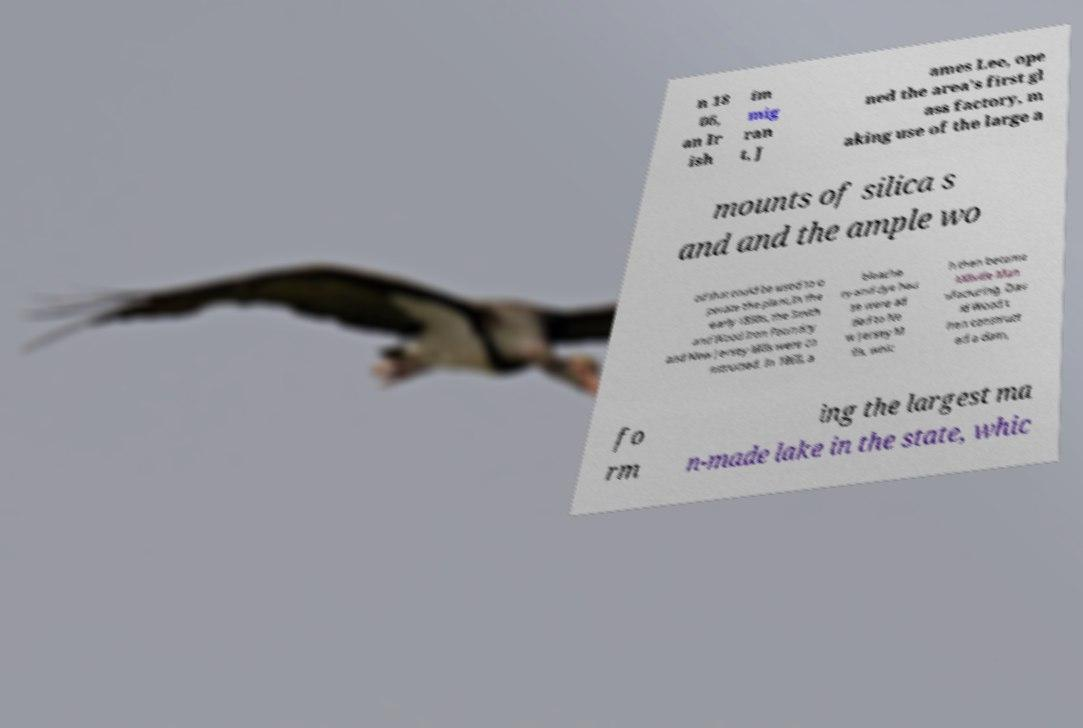I need the written content from this picture converted into text. Can you do that? n 18 06, an Ir ish im mig ran t, J ames Lee, ope ned the area's first gl ass factory, m aking use of the large a mounts of silica s and and the ample wo od that could be used to o perate the plant.In the early 1850s, the Smith and Wood Iron Foundry and New Jersey Mills were co nstructed. In 1860, a bleache ry and dye hou se were ad ded to Ne w Jersey M ills, whic h then became Millville Man ufacturing. Dav id Wood t hen construct ed a dam, fo rm ing the largest ma n-made lake in the state, whic 